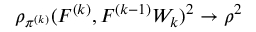Convert formula to latex. <formula><loc_0><loc_0><loc_500><loc_500>\rho _ { \pi ^ { ( k ) } } ( F ^ { ( k ) } , F ^ { ( k - 1 ) } W _ { k } ) ^ { 2 } \to \rho ^ { 2 }</formula> 